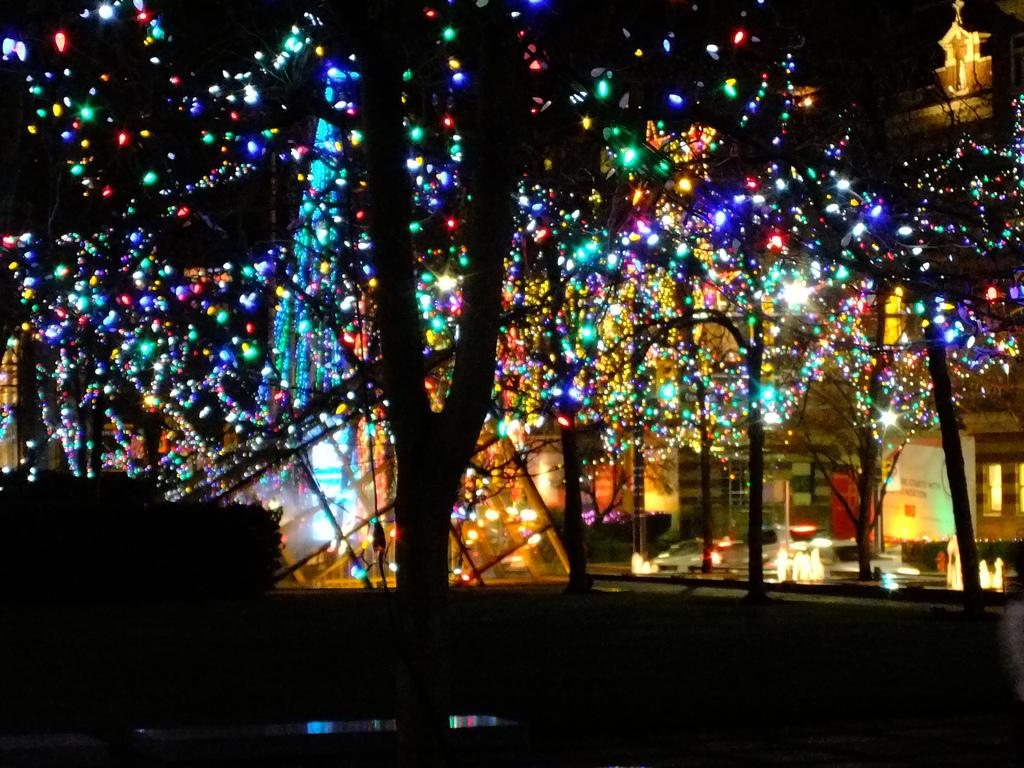What type of vegetation is visible in the image? There are trees in the image. What structure is located behind the trees? There is a building behind the trees. How is the building decorated in the image? The building is decorated with lights. What holiday is being celebrated in the image? There is no indication of a specific holiday being celebrated in the image. Can you see the person's dad giving them a kiss in the image? There is no person or any indication of a kiss in the image. 